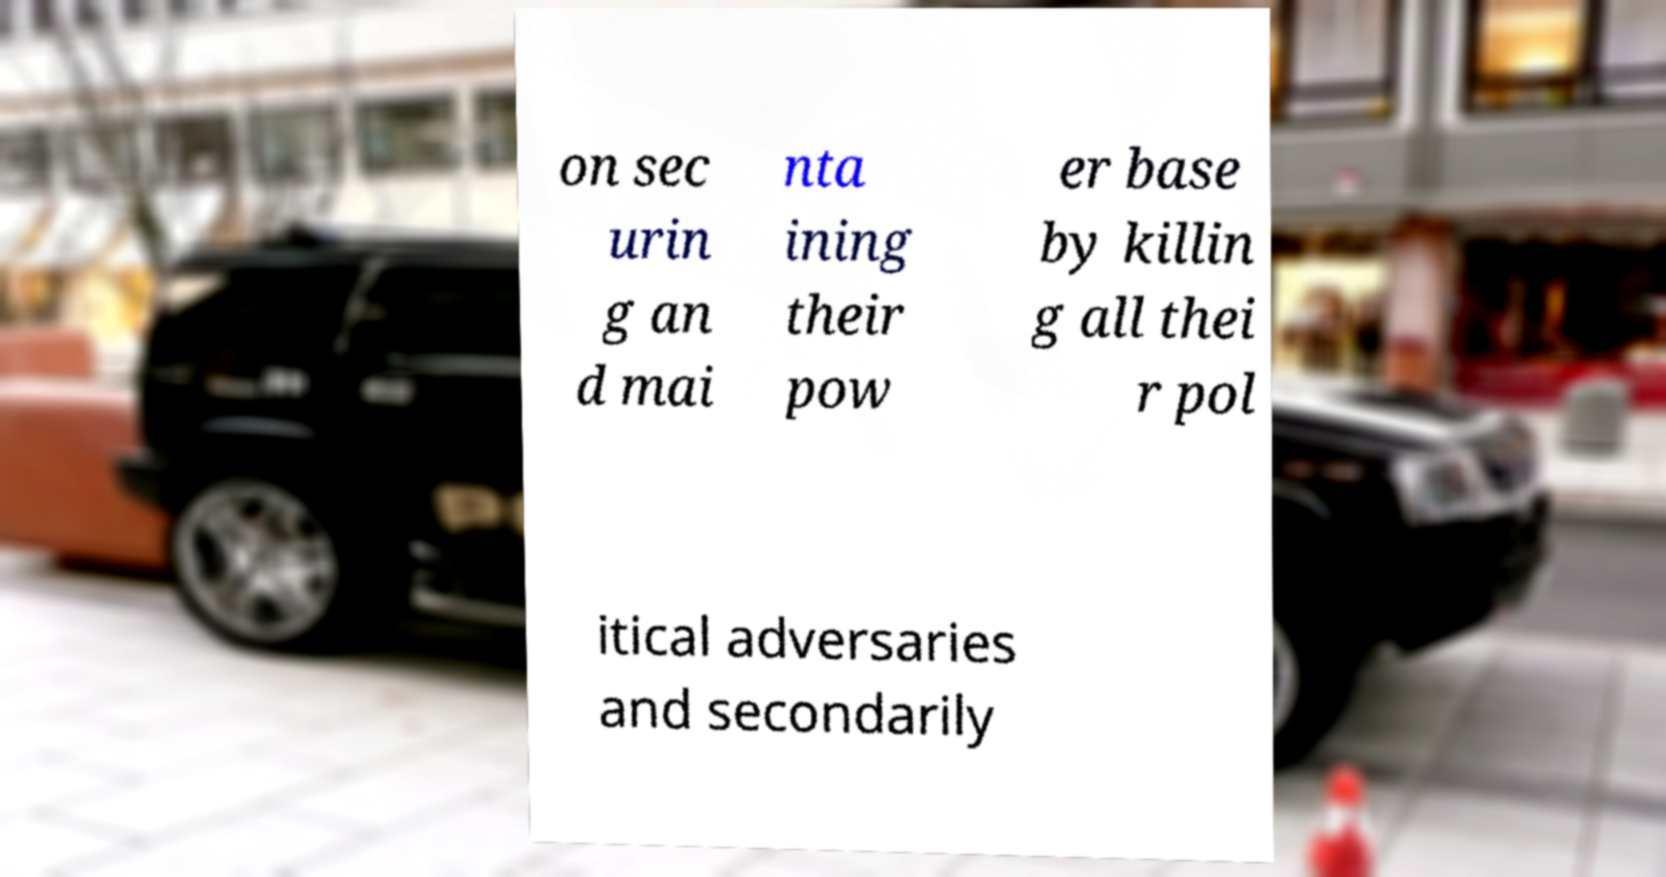There's text embedded in this image that I need extracted. Can you transcribe it verbatim? on sec urin g an d mai nta ining their pow er base by killin g all thei r pol itical adversaries and secondarily 